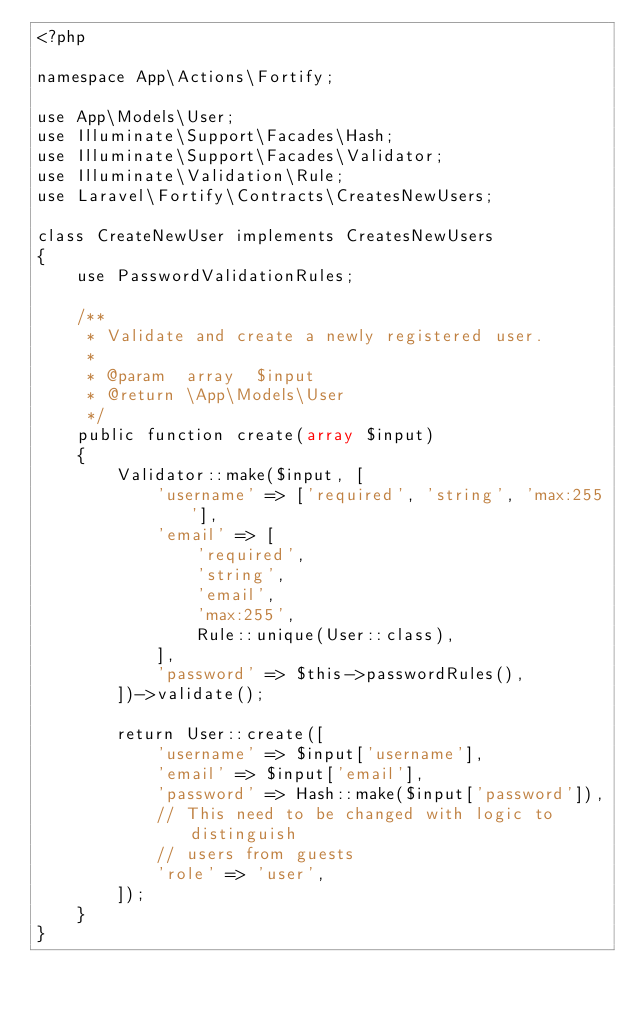Convert code to text. <code><loc_0><loc_0><loc_500><loc_500><_PHP_><?php

namespace App\Actions\Fortify;

use App\Models\User;
use Illuminate\Support\Facades\Hash;
use Illuminate\Support\Facades\Validator;
use Illuminate\Validation\Rule;
use Laravel\Fortify\Contracts\CreatesNewUsers;

class CreateNewUser implements CreatesNewUsers
{
    use PasswordValidationRules;

    /**
     * Validate and create a newly registered user.
     *
     * @param  array  $input
     * @return \App\Models\User
     */
    public function create(array $input)
    {
        Validator::make($input, [
            'username' => ['required', 'string', 'max:255'],
            'email' => [
                'required',
                'string',
                'email',
                'max:255',
                Rule::unique(User::class),
            ],
            'password' => $this->passwordRules(),
        ])->validate();

        return User::create([
            'username' => $input['username'],
            'email' => $input['email'],
            'password' => Hash::make($input['password']),
            // This need to be changed with logic to distinguish 
            // users from guests
            'role' => 'user',
        ]);
    }
}
</code> 